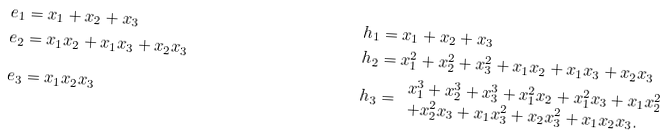Convert formula to latex. <formula><loc_0><loc_0><loc_500><loc_500>e _ { 1 } & = x _ { 1 } + x _ { 2 } + x _ { 3 } & h _ { 1 } & = x _ { 1 } + x _ { 2 } + x _ { 3 } \\ e _ { 2 } & = x _ { 1 } x _ { 2 } + x _ { 1 } x _ { 3 } + x _ { 2 } x _ { 3 } & h _ { 2 } & = x _ { 1 } ^ { 2 } + x _ { 2 } ^ { 2 } + x _ { 3 } ^ { 2 } + x _ { 1 } x _ { 2 } + x _ { 1 } x _ { 3 } + x _ { 2 } x _ { 3 } \\ e _ { 3 } & = x _ { 1 } x _ { 2 } x _ { 3 } & h _ { 3 } & = \begin{array} { l } x _ { 1 } ^ { 3 } + x _ { 2 } ^ { 3 } + x _ { 3 } ^ { 3 } + x _ { 1 } ^ { 2 } x _ { 2 } + x _ { 1 } ^ { 2 } x _ { 3 } + x _ { 1 } x _ { 2 } ^ { 2 } \\ + x _ { 2 } ^ { 2 } x _ { 3 } + x _ { 1 } x _ { 3 } ^ { 2 } + x _ { 2 } x _ { 3 } ^ { 2 } + x _ { 1 } x _ { 2 } x _ { 3 } . \end{array}</formula> 